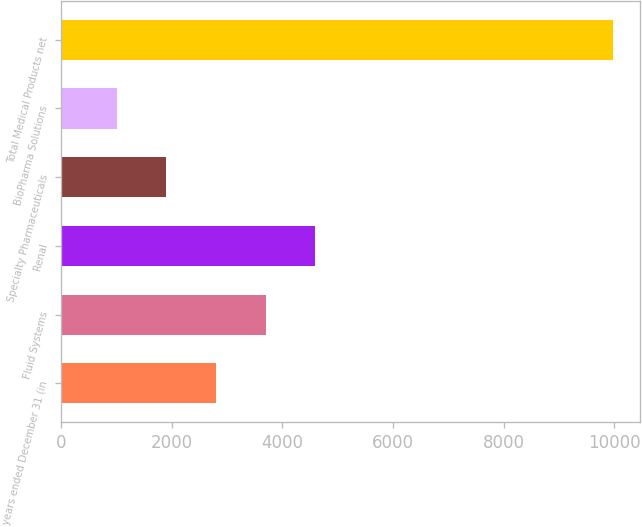<chart> <loc_0><loc_0><loc_500><loc_500><bar_chart><fcel>years ended December 31 (in<fcel>Fluid Systems<fcel>Renal<fcel>Specialty Pharmaceuticals<fcel>BioPharma Solutions<fcel>Total Medical Products net<nl><fcel>2797.6<fcel>3694.4<fcel>4591.2<fcel>1900.8<fcel>1004<fcel>9972<nl></chart> 